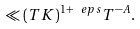<formula> <loc_0><loc_0><loc_500><loc_500>\ll ( T K ) ^ { 1 + \ e p s } T ^ { - A } .</formula> 